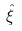<formula> <loc_0><loc_0><loc_500><loc_500>\hat { \xi }</formula> 